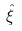<formula> <loc_0><loc_0><loc_500><loc_500>\hat { \xi }</formula> 